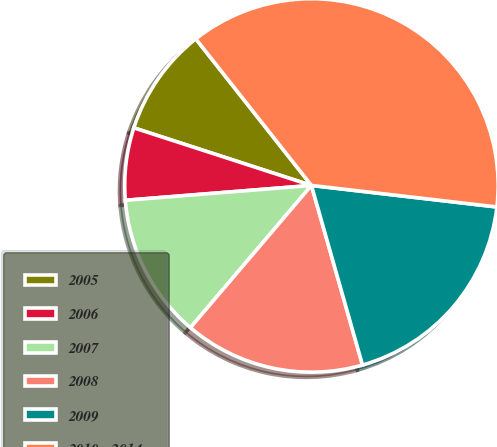<chart> <loc_0><loc_0><loc_500><loc_500><pie_chart><fcel>2005<fcel>2006<fcel>2007<fcel>2008<fcel>2009<fcel>2010 - 2014<nl><fcel>9.38%<fcel>6.26%<fcel>12.51%<fcel>15.63%<fcel>18.75%<fcel>37.47%<nl></chart> 